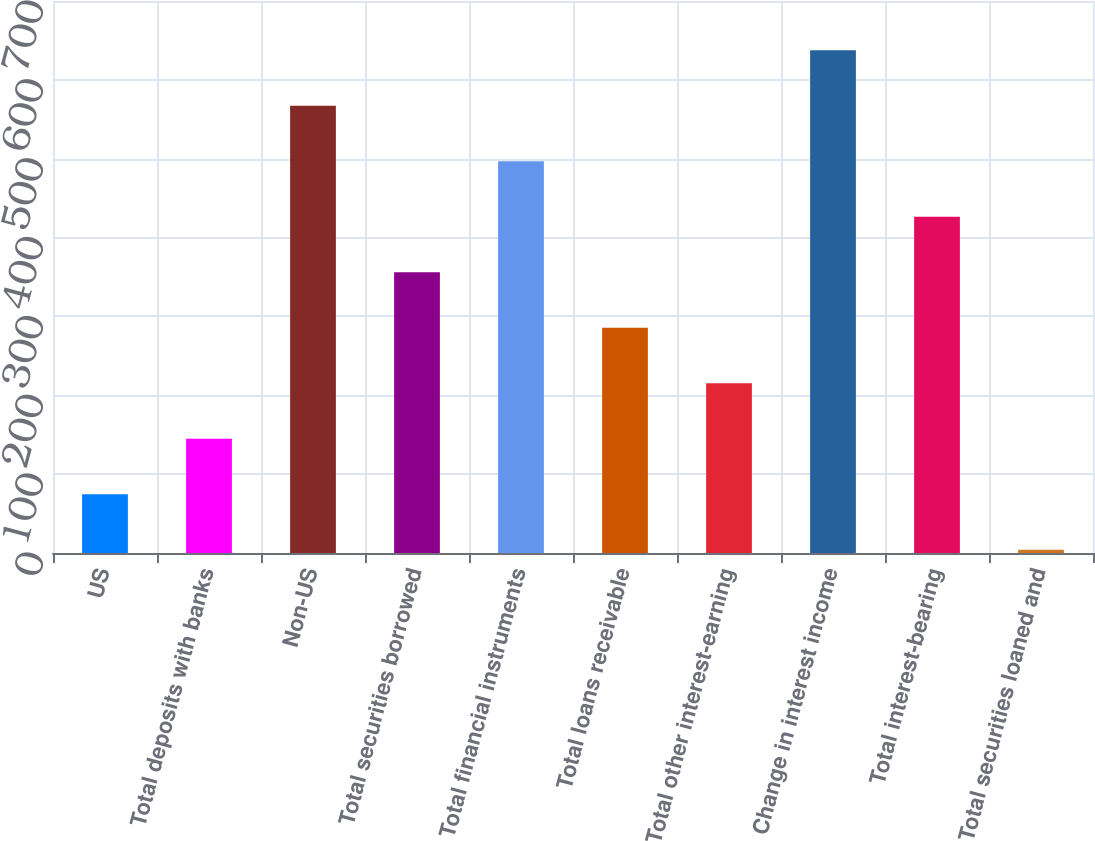Convert chart to OTSL. <chart><loc_0><loc_0><loc_500><loc_500><bar_chart><fcel>US<fcel>Total deposits with banks<fcel>Non-US<fcel>Total securities borrowed<fcel>Total financial instruments<fcel>Total loans receivable<fcel>Total other interest-earning<fcel>Change in interest income<fcel>Total interest-bearing<fcel>Total securities loaned and<nl><fcel>74.4<fcel>144.8<fcel>567.2<fcel>356<fcel>496.8<fcel>285.6<fcel>215.2<fcel>637.6<fcel>426.4<fcel>4<nl></chart> 